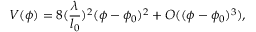<formula> <loc_0><loc_0><loc_500><loc_500>V ( \phi ) = 8 ( \frac { \lambda } { l _ { 0 } } ) ^ { 2 } ( \phi - \phi _ { 0 } ) ^ { 2 } + O ( ( \phi - \phi _ { 0 } ) ^ { 3 } ) ,</formula> 